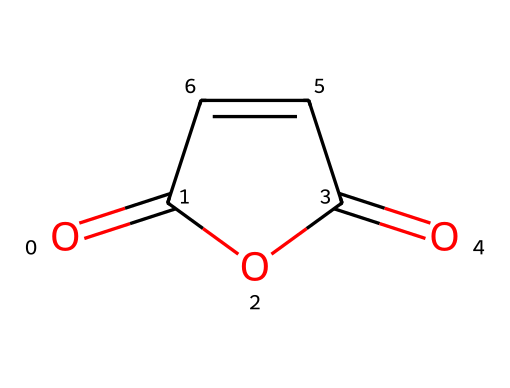What is the molecular formula of maleic anhydride? The molecular formula can be derived by counting the types of atoms represented in the SMILES structure. The structure includes 4 carbon atoms, 4 hydrogen atoms, and 3 oxygen atoms, leading to the molecular formula C4H2O3.
Answer: C4H2O3 How many rings are present in maleic anhydride? To identify rings, we look for circular connections in the SMILES representation. The presence of two carbonyl groups and the cyclic structure indicates a ring. Here, there is one ring in the structure.
Answer: 1 What type of functional groups are present in maleic anhydride? Examining the structure reveals that maleic anhydride contains two carbonyl (C=O) groups. Additionally, it has an anhydride functional group due to the cyclic connection of carbon and oxygen atoms.
Answer: anhydride and carbonyl groups How many double bonds does maleic anhydride have? The structure shows two distinct double bonds: one in the C=O (carbonyl) groups and another in the C=C (double bond between carbon atoms). Therefore, there are two double bonds present.
Answer: 2 What is the primary use of maleic anhydride in polymers? Maleic anhydride is primarily used as a monomer in the synthesis of fire-resistant polymers due to its reactive anhydride group, which can form strong cross-links in polymer chains.
Answer: fire-resistant polymers What is the role of maleic anhydride in fire-resistant applications? Maleic anhydride acts as a reactive component that can improve the thermal stability and fire resistance of polymers when synthesized as a copolymer or used to modify existing polymers.
Answer: enhances thermal stability Is maleic anhydride considered a hazardous material? Yes, based on its properties and potential health effects, maleic anhydride is classified as hazardous due to its irritative nature and can cause respiratory distress, and thus should be handled with care.
Answer: yes 